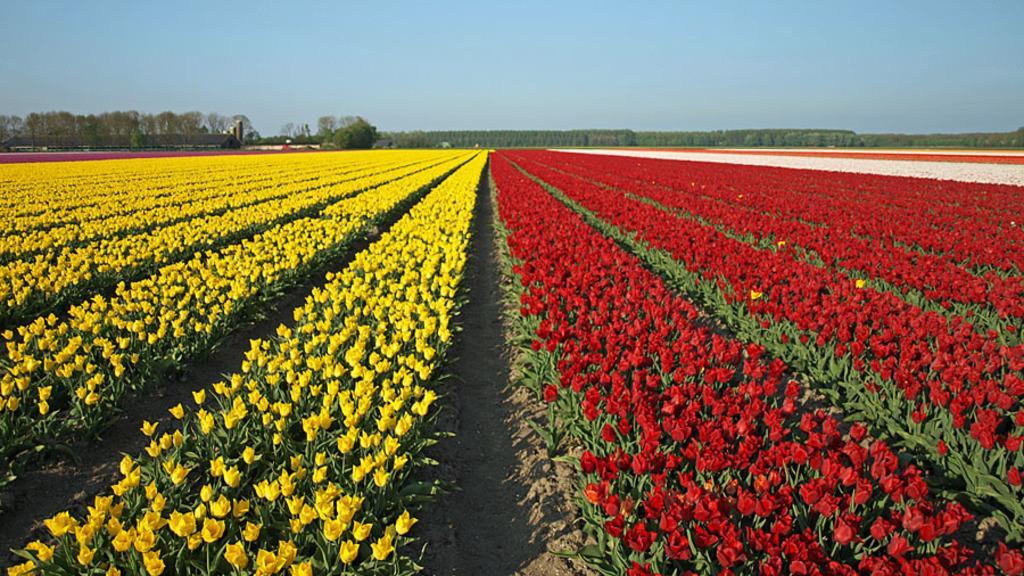Can you describe this image briefly? In this picture I can see flower fields. I can see trees. I can see clouds in the sky. 